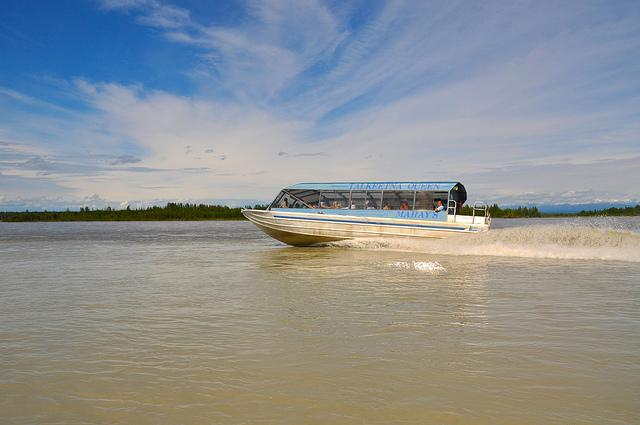What is this watercraft's purpose?

Choices:
A) research
B) excursions
C) fishing
D) hunting excursions 